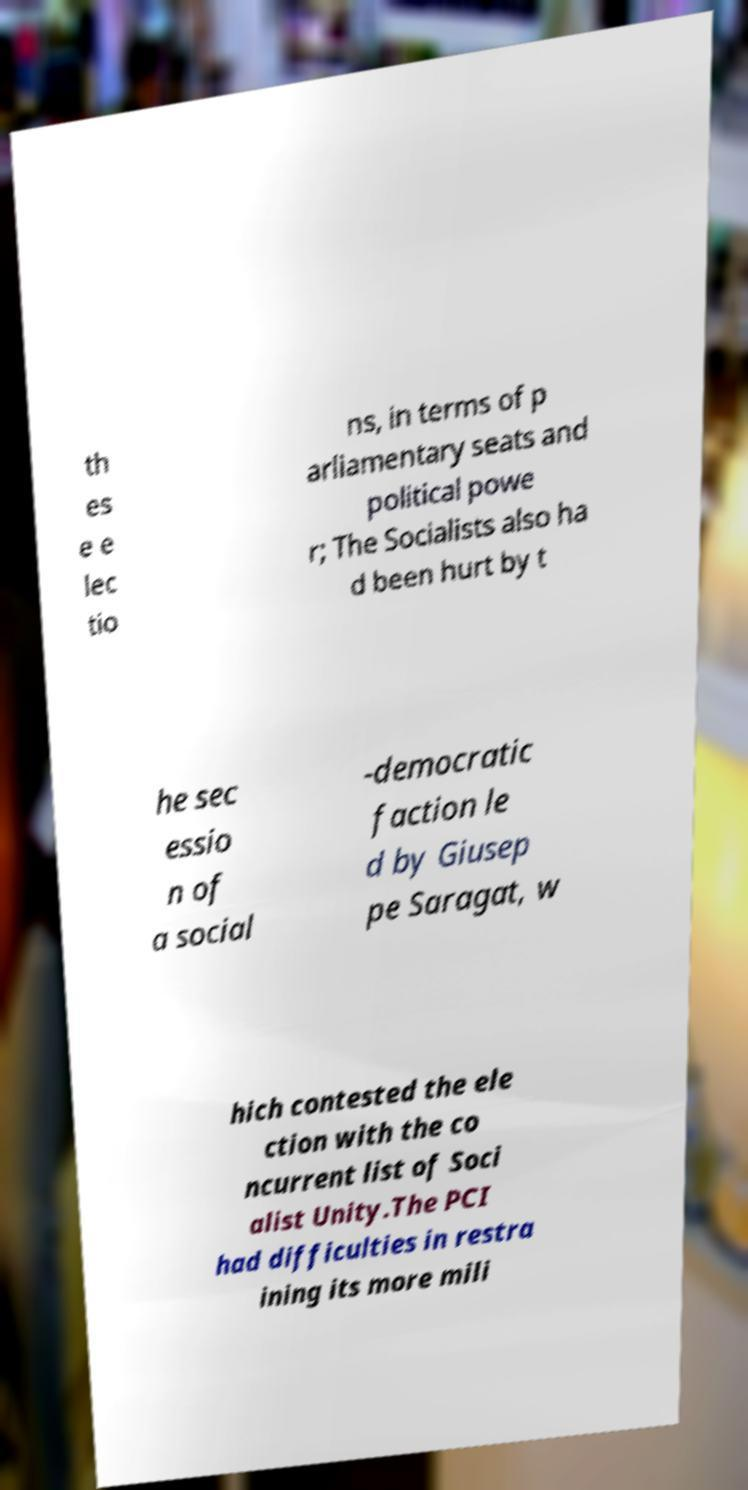Could you extract and type out the text from this image? th es e e lec tio ns, in terms of p arliamentary seats and political powe r; The Socialists also ha d been hurt by t he sec essio n of a social -democratic faction le d by Giusep pe Saragat, w hich contested the ele ction with the co ncurrent list of Soci alist Unity.The PCI had difficulties in restra ining its more mili 